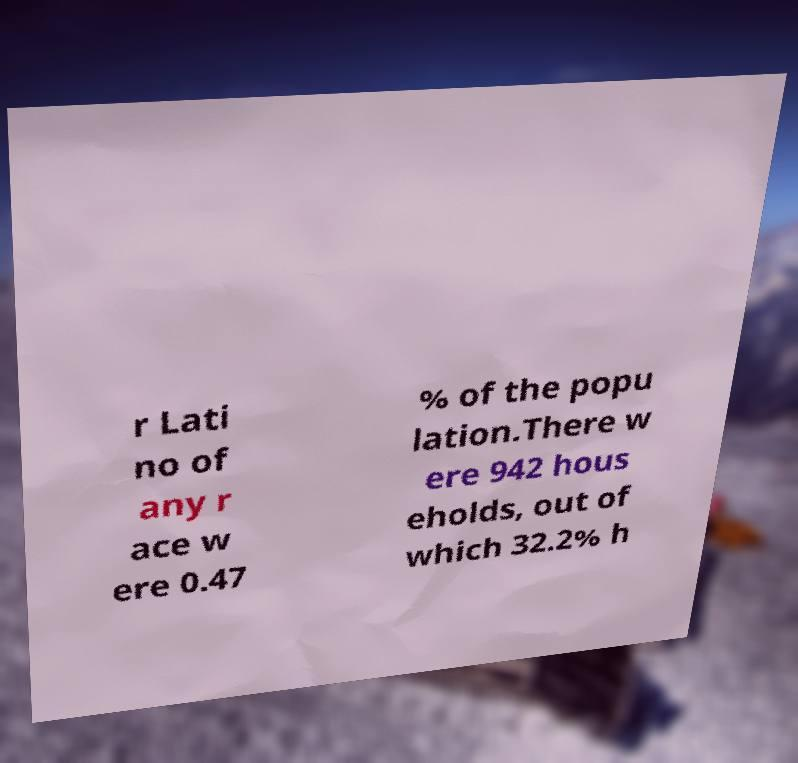Please read and relay the text visible in this image. What does it say? r Lati no of any r ace w ere 0.47 % of the popu lation.There w ere 942 hous eholds, out of which 32.2% h 